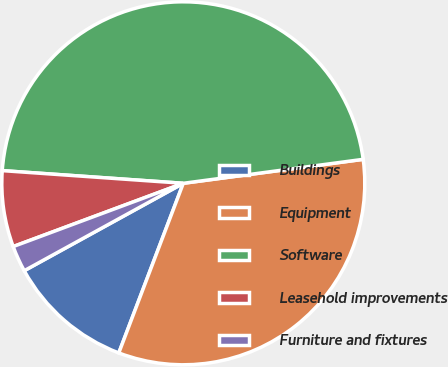Convert chart to OTSL. <chart><loc_0><loc_0><loc_500><loc_500><pie_chart><fcel>Buildings<fcel>Equipment<fcel>Software<fcel>Leasehold improvements<fcel>Furniture and fixtures<nl><fcel>11.22%<fcel>32.89%<fcel>46.78%<fcel>6.78%<fcel>2.33%<nl></chart> 